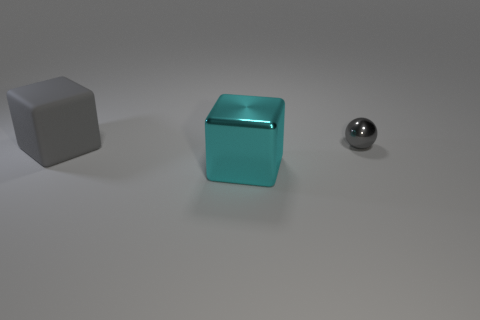Add 3 tiny yellow cylinders. How many objects exist? 6 Subtract all cubes. How many objects are left? 1 Add 1 cyan shiny cubes. How many cyan shiny cubes are left? 2 Add 1 matte objects. How many matte objects exist? 2 Subtract 0 brown blocks. How many objects are left? 3 Subtract all large metallic cubes. Subtract all blue blocks. How many objects are left? 2 